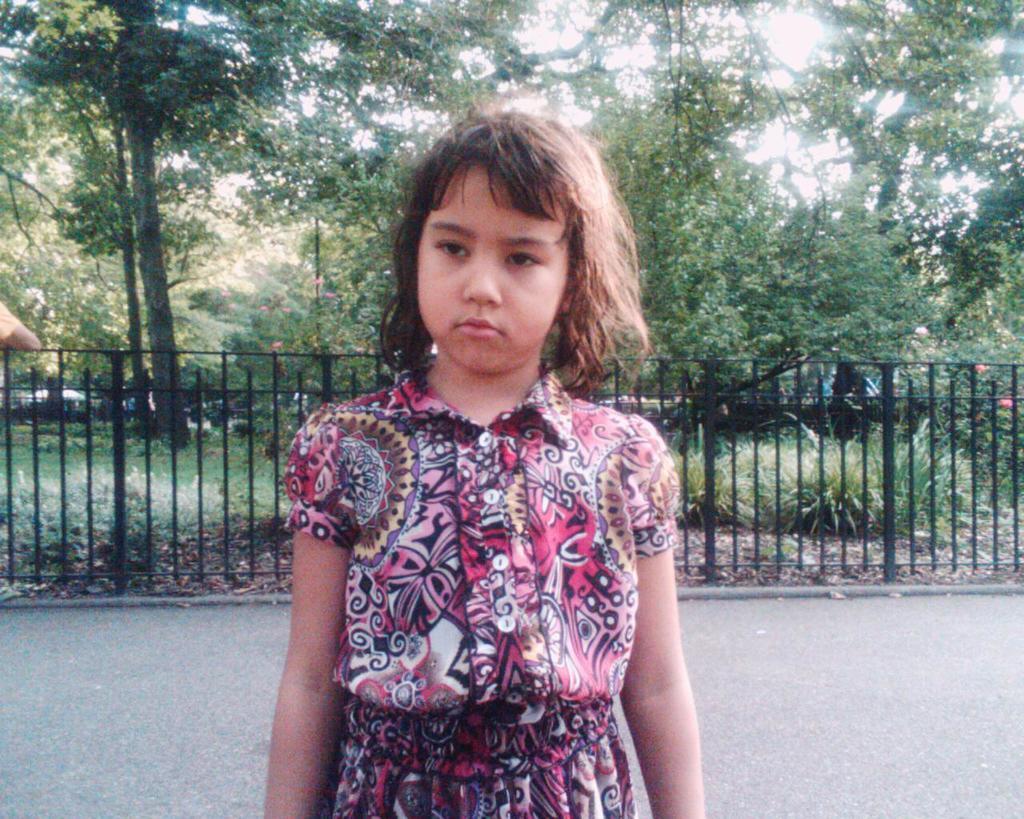Could you give a brief overview of what you see in this image? In this image we can see one girl standing. And we can see the metal fencing. And we can see the trees and plants. 